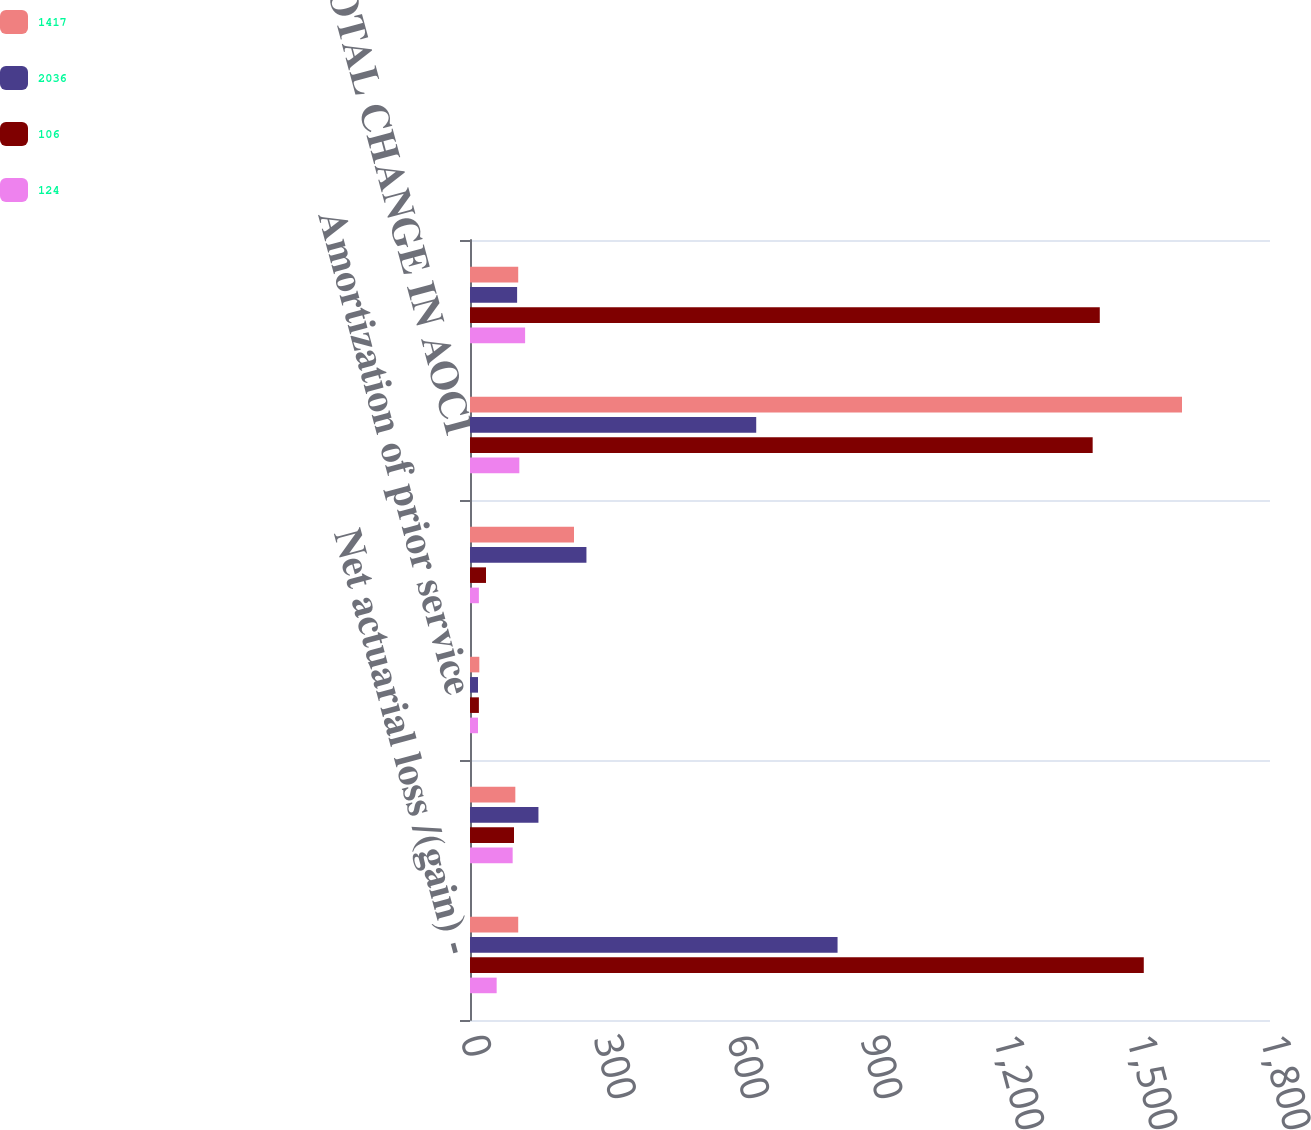Convert chart. <chart><loc_0><loc_0><loc_500><loc_500><stacked_bar_chart><ecel><fcel>Net actuarial loss /(gain) -<fcel>Amortization of net actuarial<fcel>Amortization of prior service<fcel>Currency translation and other<fcel>TOTAL CHANGE IN AOCI<fcel>NET AMOUNTS RECOGNIZED IN<nl><fcel>1417<fcel>108.5<fcel>102<fcel>21<fcel>234<fcel>1602<fcel>108.5<nl><fcel>2036<fcel>827<fcel>154<fcel>18<fcel>262<fcel>644<fcel>106<nl><fcel>106<fcel>1516<fcel>99<fcel>20<fcel>36<fcel>1401<fcel>1417<nl><fcel>124<fcel>60<fcel>96<fcel>18<fcel>20<fcel>111<fcel>124<nl></chart> 